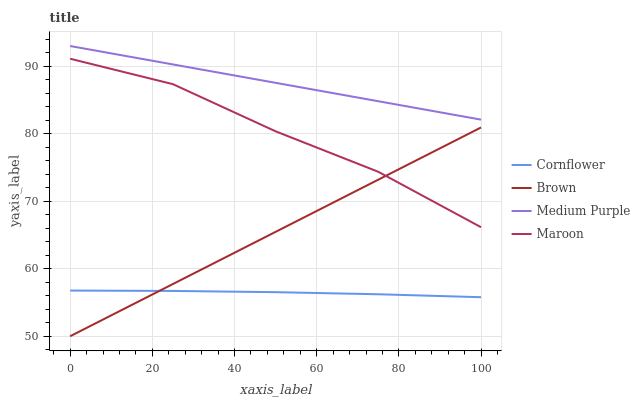Does Cornflower have the minimum area under the curve?
Answer yes or no. Yes. Does Medium Purple have the maximum area under the curve?
Answer yes or no. Yes. Does Maroon have the minimum area under the curve?
Answer yes or no. No. Does Maroon have the maximum area under the curve?
Answer yes or no. No. Is Brown the smoothest?
Answer yes or no. Yes. Is Maroon the roughest?
Answer yes or no. Yes. Is Cornflower the smoothest?
Answer yes or no. No. Is Cornflower the roughest?
Answer yes or no. No. Does Cornflower have the lowest value?
Answer yes or no. No. Does Medium Purple have the highest value?
Answer yes or no. Yes. Does Maroon have the highest value?
Answer yes or no. No. Is Cornflower less than Medium Purple?
Answer yes or no. Yes. Is Medium Purple greater than Cornflower?
Answer yes or no. Yes. Does Brown intersect Maroon?
Answer yes or no. Yes. Is Brown less than Maroon?
Answer yes or no. No. Is Brown greater than Maroon?
Answer yes or no. No. Does Cornflower intersect Medium Purple?
Answer yes or no. No. 